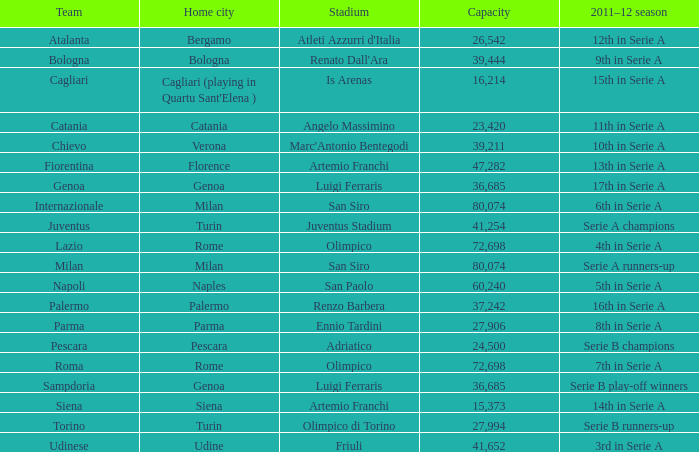What team had a capacity of over 26,542, a home city of milan, and finished the 2011-2012 season 6th in serie a? Internazionale. 